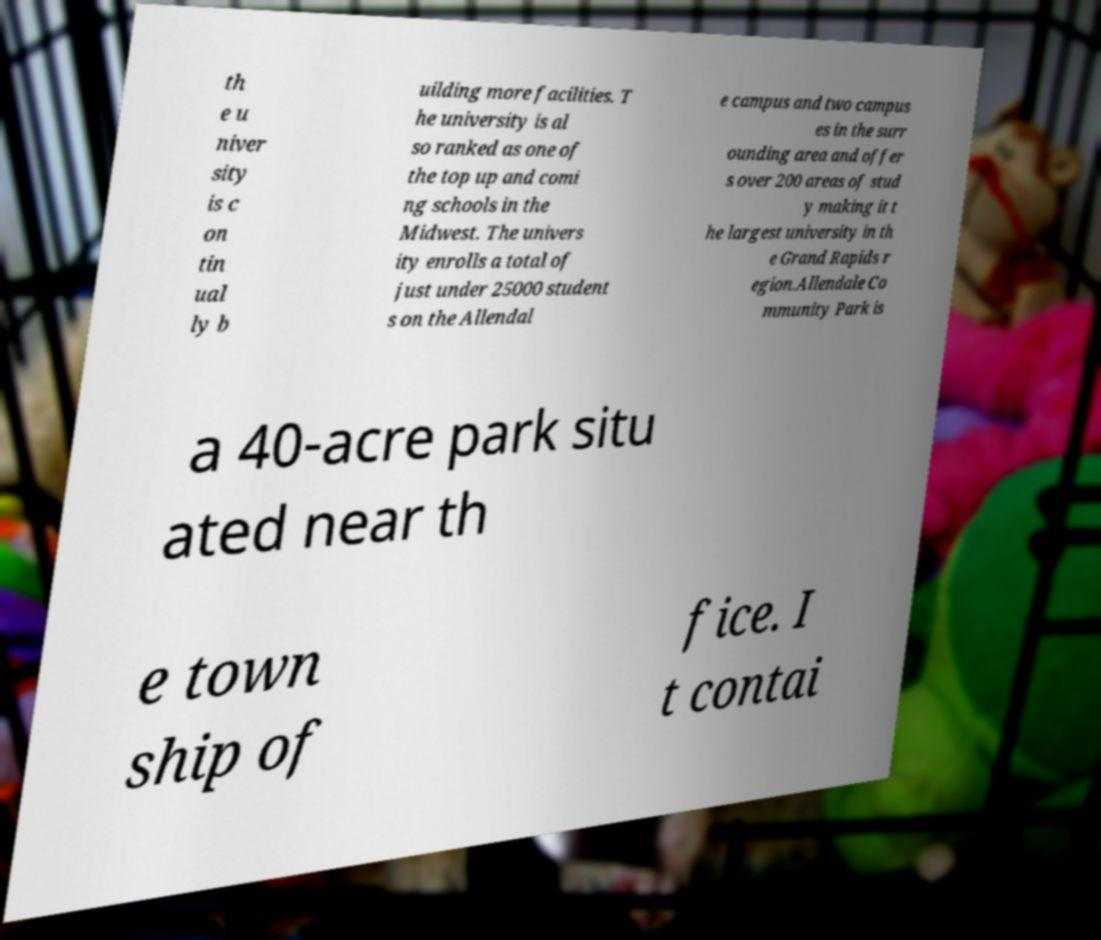What messages or text are displayed in this image? I need them in a readable, typed format. th e u niver sity is c on tin ual ly b uilding more facilities. T he university is al so ranked as one of the top up and comi ng schools in the Midwest. The univers ity enrolls a total of just under 25000 student s on the Allendal e campus and two campus es in the surr ounding area and offer s over 200 areas of stud y making it t he largest university in th e Grand Rapids r egion.Allendale Co mmunity Park is a 40-acre park situ ated near th e town ship of fice. I t contai 